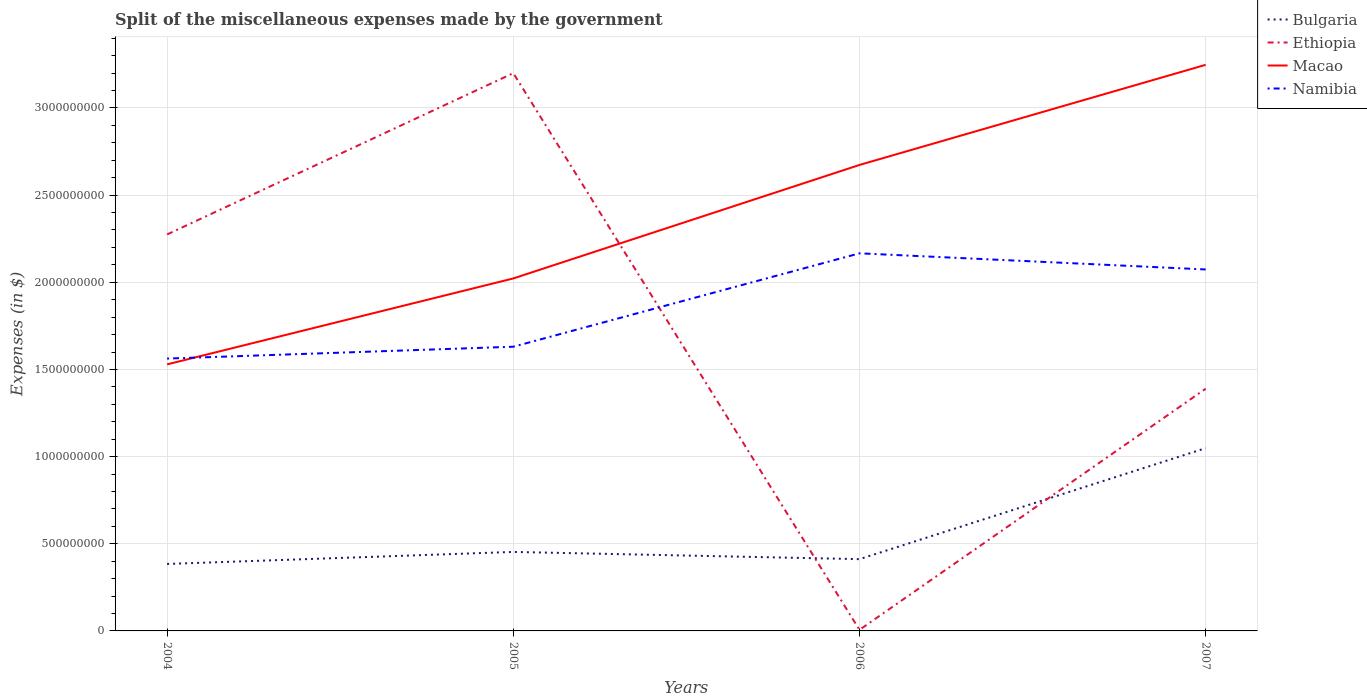How many different coloured lines are there?
Your answer should be very brief. 4. Is the number of lines equal to the number of legend labels?
Offer a very short reply. Yes. Across all years, what is the maximum miscellaneous expenses made by the government in Macao?
Ensure brevity in your answer.  1.53e+09. In which year was the miscellaneous expenses made by the government in Ethiopia maximum?
Keep it short and to the point. 2006. What is the total miscellaneous expenses made by the government in Macao in the graph?
Offer a very short reply. -1.14e+09. What is the difference between the highest and the second highest miscellaneous expenses made by the government in Macao?
Provide a short and direct response. 1.72e+09. Is the miscellaneous expenses made by the government in Bulgaria strictly greater than the miscellaneous expenses made by the government in Ethiopia over the years?
Your response must be concise. No. How many years are there in the graph?
Offer a terse response. 4. Does the graph contain any zero values?
Your response must be concise. No. Where does the legend appear in the graph?
Provide a short and direct response. Top right. How many legend labels are there?
Offer a terse response. 4. What is the title of the graph?
Ensure brevity in your answer.  Split of the miscellaneous expenses made by the government. Does "Sub-Saharan Africa (developing only)" appear as one of the legend labels in the graph?
Provide a succinct answer. No. What is the label or title of the Y-axis?
Make the answer very short. Expenses (in $). What is the Expenses (in $) of Bulgaria in 2004?
Your response must be concise. 3.84e+08. What is the Expenses (in $) of Ethiopia in 2004?
Make the answer very short. 2.27e+09. What is the Expenses (in $) of Macao in 2004?
Your answer should be compact. 1.53e+09. What is the Expenses (in $) of Namibia in 2004?
Keep it short and to the point. 1.56e+09. What is the Expenses (in $) of Bulgaria in 2005?
Your answer should be very brief. 4.53e+08. What is the Expenses (in $) in Ethiopia in 2005?
Ensure brevity in your answer.  3.20e+09. What is the Expenses (in $) in Macao in 2005?
Your answer should be very brief. 2.02e+09. What is the Expenses (in $) of Namibia in 2005?
Your answer should be compact. 1.63e+09. What is the Expenses (in $) of Bulgaria in 2006?
Offer a very short reply. 4.12e+08. What is the Expenses (in $) of Ethiopia in 2006?
Your response must be concise. 6.20e+06. What is the Expenses (in $) of Macao in 2006?
Your response must be concise. 2.67e+09. What is the Expenses (in $) of Namibia in 2006?
Your response must be concise. 2.17e+09. What is the Expenses (in $) of Bulgaria in 2007?
Keep it short and to the point. 1.05e+09. What is the Expenses (in $) in Ethiopia in 2007?
Ensure brevity in your answer.  1.39e+09. What is the Expenses (in $) in Macao in 2007?
Make the answer very short. 3.25e+09. What is the Expenses (in $) of Namibia in 2007?
Give a very brief answer. 2.07e+09. Across all years, what is the maximum Expenses (in $) in Bulgaria?
Provide a short and direct response. 1.05e+09. Across all years, what is the maximum Expenses (in $) in Ethiopia?
Your response must be concise. 3.20e+09. Across all years, what is the maximum Expenses (in $) in Macao?
Offer a terse response. 3.25e+09. Across all years, what is the maximum Expenses (in $) in Namibia?
Make the answer very short. 2.17e+09. Across all years, what is the minimum Expenses (in $) of Bulgaria?
Offer a terse response. 3.84e+08. Across all years, what is the minimum Expenses (in $) in Ethiopia?
Ensure brevity in your answer.  6.20e+06. Across all years, what is the minimum Expenses (in $) of Macao?
Offer a very short reply. 1.53e+09. Across all years, what is the minimum Expenses (in $) of Namibia?
Give a very brief answer. 1.56e+09. What is the total Expenses (in $) of Bulgaria in the graph?
Make the answer very short. 2.30e+09. What is the total Expenses (in $) in Ethiopia in the graph?
Provide a succinct answer. 6.87e+09. What is the total Expenses (in $) of Macao in the graph?
Ensure brevity in your answer.  9.47e+09. What is the total Expenses (in $) in Namibia in the graph?
Your response must be concise. 7.43e+09. What is the difference between the Expenses (in $) of Bulgaria in 2004 and that in 2005?
Your answer should be compact. -6.90e+07. What is the difference between the Expenses (in $) in Ethiopia in 2004 and that in 2005?
Offer a terse response. -9.25e+08. What is the difference between the Expenses (in $) of Macao in 2004 and that in 2005?
Your answer should be very brief. -4.93e+08. What is the difference between the Expenses (in $) in Namibia in 2004 and that in 2005?
Your response must be concise. -6.80e+07. What is the difference between the Expenses (in $) of Bulgaria in 2004 and that in 2006?
Keep it short and to the point. -2.76e+07. What is the difference between the Expenses (in $) in Ethiopia in 2004 and that in 2006?
Offer a terse response. 2.27e+09. What is the difference between the Expenses (in $) of Macao in 2004 and that in 2006?
Your answer should be compact. -1.14e+09. What is the difference between the Expenses (in $) in Namibia in 2004 and that in 2006?
Make the answer very short. -6.04e+08. What is the difference between the Expenses (in $) of Bulgaria in 2004 and that in 2007?
Your answer should be very brief. -6.64e+08. What is the difference between the Expenses (in $) of Ethiopia in 2004 and that in 2007?
Offer a very short reply. 8.85e+08. What is the difference between the Expenses (in $) in Macao in 2004 and that in 2007?
Your answer should be compact. -1.72e+09. What is the difference between the Expenses (in $) in Namibia in 2004 and that in 2007?
Keep it short and to the point. -5.11e+08. What is the difference between the Expenses (in $) of Bulgaria in 2005 and that in 2006?
Give a very brief answer. 4.15e+07. What is the difference between the Expenses (in $) of Ethiopia in 2005 and that in 2006?
Give a very brief answer. 3.19e+09. What is the difference between the Expenses (in $) of Macao in 2005 and that in 2006?
Give a very brief answer. -6.51e+08. What is the difference between the Expenses (in $) of Namibia in 2005 and that in 2006?
Make the answer very short. -5.36e+08. What is the difference between the Expenses (in $) in Bulgaria in 2005 and that in 2007?
Your answer should be compact. -5.95e+08. What is the difference between the Expenses (in $) of Ethiopia in 2005 and that in 2007?
Provide a succinct answer. 1.81e+09. What is the difference between the Expenses (in $) in Macao in 2005 and that in 2007?
Provide a succinct answer. -1.23e+09. What is the difference between the Expenses (in $) of Namibia in 2005 and that in 2007?
Offer a terse response. -4.43e+08. What is the difference between the Expenses (in $) of Bulgaria in 2006 and that in 2007?
Your response must be concise. -6.37e+08. What is the difference between the Expenses (in $) in Ethiopia in 2006 and that in 2007?
Make the answer very short. -1.38e+09. What is the difference between the Expenses (in $) of Macao in 2006 and that in 2007?
Your answer should be compact. -5.74e+08. What is the difference between the Expenses (in $) in Namibia in 2006 and that in 2007?
Your response must be concise. 9.26e+07. What is the difference between the Expenses (in $) in Bulgaria in 2004 and the Expenses (in $) in Ethiopia in 2005?
Offer a terse response. -2.82e+09. What is the difference between the Expenses (in $) of Bulgaria in 2004 and the Expenses (in $) of Macao in 2005?
Your response must be concise. -1.64e+09. What is the difference between the Expenses (in $) in Bulgaria in 2004 and the Expenses (in $) in Namibia in 2005?
Ensure brevity in your answer.  -1.25e+09. What is the difference between the Expenses (in $) in Ethiopia in 2004 and the Expenses (in $) in Macao in 2005?
Your response must be concise. 2.52e+08. What is the difference between the Expenses (in $) of Ethiopia in 2004 and the Expenses (in $) of Namibia in 2005?
Your answer should be very brief. 6.44e+08. What is the difference between the Expenses (in $) in Macao in 2004 and the Expenses (in $) in Namibia in 2005?
Provide a short and direct response. -1.01e+08. What is the difference between the Expenses (in $) in Bulgaria in 2004 and the Expenses (in $) in Ethiopia in 2006?
Make the answer very short. 3.78e+08. What is the difference between the Expenses (in $) of Bulgaria in 2004 and the Expenses (in $) of Macao in 2006?
Make the answer very short. -2.29e+09. What is the difference between the Expenses (in $) in Bulgaria in 2004 and the Expenses (in $) in Namibia in 2006?
Make the answer very short. -1.78e+09. What is the difference between the Expenses (in $) of Ethiopia in 2004 and the Expenses (in $) of Macao in 2006?
Provide a succinct answer. -3.99e+08. What is the difference between the Expenses (in $) in Ethiopia in 2004 and the Expenses (in $) in Namibia in 2006?
Keep it short and to the point. 1.08e+08. What is the difference between the Expenses (in $) in Macao in 2004 and the Expenses (in $) in Namibia in 2006?
Provide a short and direct response. -6.37e+08. What is the difference between the Expenses (in $) of Bulgaria in 2004 and the Expenses (in $) of Ethiopia in 2007?
Make the answer very short. -1.01e+09. What is the difference between the Expenses (in $) of Bulgaria in 2004 and the Expenses (in $) of Macao in 2007?
Keep it short and to the point. -2.86e+09. What is the difference between the Expenses (in $) of Bulgaria in 2004 and the Expenses (in $) of Namibia in 2007?
Offer a terse response. -1.69e+09. What is the difference between the Expenses (in $) in Ethiopia in 2004 and the Expenses (in $) in Macao in 2007?
Offer a very short reply. -9.73e+08. What is the difference between the Expenses (in $) of Ethiopia in 2004 and the Expenses (in $) of Namibia in 2007?
Give a very brief answer. 2.01e+08. What is the difference between the Expenses (in $) in Macao in 2004 and the Expenses (in $) in Namibia in 2007?
Ensure brevity in your answer.  -5.44e+08. What is the difference between the Expenses (in $) in Bulgaria in 2005 and the Expenses (in $) in Ethiopia in 2006?
Offer a terse response. 4.47e+08. What is the difference between the Expenses (in $) of Bulgaria in 2005 and the Expenses (in $) of Macao in 2006?
Make the answer very short. -2.22e+09. What is the difference between the Expenses (in $) of Bulgaria in 2005 and the Expenses (in $) of Namibia in 2006?
Give a very brief answer. -1.71e+09. What is the difference between the Expenses (in $) of Ethiopia in 2005 and the Expenses (in $) of Macao in 2006?
Give a very brief answer. 5.27e+08. What is the difference between the Expenses (in $) of Ethiopia in 2005 and the Expenses (in $) of Namibia in 2006?
Ensure brevity in your answer.  1.03e+09. What is the difference between the Expenses (in $) of Macao in 2005 and the Expenses (in $) of Namibia in 2006?
Your response must be concise. -1.44e+08. What is the difference between the Expenses (in $) in Bulgaria in 2005 and the Expenses (in $) in Ethiopia in 2007?
Your answer should be very brief. -9.36e+08. What is the difference between the Expenses (in $) of Bulgaria in 2005 and the Expenses (in $) of Macao in 2007?
Keep it short and to the point. -2.79e+09. What is the difference between the Expenses (in $) of Bulgaria in 2005 and the Expenses (in $) of Namibia in 2007?
Provide a succinct answer. -1.62e+09. What is the difference between the Expenses (in $) in Ethiopia in 2005 and the Expenses (in $) in Macao in 2007?
Your answer should be compact. -4.77e+07. What is the difference between the Expenses (in $) of Ethiopia in 2005 and the Expenses (in $) of Namibia in 2007?
Keep it short and to the point. 1.13e+09. What is the difference between the Expenses (in $) of Macao in 2005 and the Expenses (in $) of Namibia in 2007?
Offer a very short reply. -5.15e+07. What is the difference between the Expenses (in $) of Bulgaria in 2006 and the Expenses (in $) of Ethiopia in 2007?
Ensure brevity in your answer.  -9.78e+08. What is the difference between the Expenses (in $) in Bulgaria in 2006 and the Expenses (in $) in Macao in 2007?
Your answer should be compact. -2.84e+09. What is the difference between the Expenses (in $) of Bulgaria in 2006 and the Expenses (in $) of Namibia in 2007?
Offer a terse response. -1.66e+09. What is the difference between the Expenses (in $) in Ethiopia in 2006 and the Expenses (in $) in Macao in 2007?
Your answer should be compact. -3.24e+09. What is the difference between the Expenses (in $) in Ethiopia in 2006 and the Expenses (in $) in Namibia in 2007?
Give a very brief answer. -2.07e+09. What is the difference between the Expenses (in $) of Macao in 2006 and the Expenses (in $) of Namibia in 2007?
Provide a succinct answer. 6.00e+08. What is the average Expenses (in $) of Bulgaria per year?
Your response must be concise. 5.74e+08. What is the average Expenses (in $) of Ethiopia per year?
Provide a short and direct response. 1.72e+09. What is the average Expenses (in $) in Macao per year?
Your answer should be very brief. 2.37e+09. What is the average Expenses (in $) of Namibia per year?
Your answer should be compact. 1.86e+09. In the year 2004, what is the difference between the Expenses (in $) of Bulgaria and Expenses (in $) of Ethiopia?
Provide a succinct answer. -1.89e+09. In the year 2004, what is the difference between the Expenses (in $) in Bulgaria and Expenses (in $) in Macao?
Offer a very short reply. -1.14e+09. In the year 2004, what is the difference between the Expenses (in $) of Bulgaria and Expenses (in $) of Namibia?
Your answer should be compact. -1.18e+09. In the year 2004, what is the difference between the Expenses (in $) in Ethiopia and Expenses (in $) in Macao?
Your answer should be very brief. 7.45e+08. In the year 2004, what is the difference between the Expenses (in $) in Ethiopia and Expenses (in $) in Namibia?
Make the answer very short. 7.12e+08. In the year 2004, what is the difference between the Expenses (in $) of Macao and Expenses (in $) of Namibia?
Your answer should be very brief. -3.33e+07. In the year 2005, what is the difference between the Expenses (in $) of Bulgaria and Expenses (in $) of Ethiopia?
Offer a very short reply. -2.75e+09. In the year 2005, what is the difference between the Expenses (in $) in Bulgaria and Expenses (in $) in Macao?
Your answer should be very brief. -1.57e+09. In the year 2005, what is the difference between the Expenses (in $) of Bulgaria and Expenses (in $) of Namibia?
Give a very brief answer. -1.18e+09. In the year 2005, what is the difference between the Expenses (in $) of Ethiopia and Expenses (in $) of Macao?
Provide a succinct answer. 1.18e+09. In the year 2005, what is the difference between the Expenses (in $) of Ethiopia and Expenses (in $) of Namibia?
Give a very brief answer. 1.57e+09. In the year 2005, what is the difference between the Expenses (in $) in Macao and Expenses (in $) in Namibia?
Your response must be concise. 3.92e+08. In the year 2006, what is the difference between the Expenses (in $) in Bulgaria and Expenses (in $) in Ethiopia?
Ensure brevity in your answer.  4.05e+08. In the year 2006, what is the difference between the Expenses (in $) in Bulgaria and Expenses (in $) in Macao?
Offer a very short reply. -2.26e+09. In the year 2006, what is the difference between the Expenses (in $) of Bulgaria and Expenses (in $) of Namibia?
Give a very brief answer. -1.75e+09. In the year 2006, what is the difference between the Expenses (in $) of Ethiopia and Expenses (in $) of Macao?
Offer a very short reply. -2.67e+09. In the year 2006, what is the difference between the Expenses (in $) of Ethiopia and Expenses (in $) of Namibia?
Your response must be concise. -2.16e+09. In the year 2006, what is the difference between the Expenses (in $) in Macao and Expenses (in $) in Namibia?
Ensure brevity in your answer.  5.07e+08. In the year 2007, what is the difference between the Expenses (in $) in Bulgaria and Expenses (in $) in Ethiopia?
Your response must be concise. -3.41e+08. In the year 2007, what is the difference between the Expenses (in $) of Bulgaria and Expenses (in $) of Macao?
Make the answer very short. -2.20e+09. In the year 2007, what is the difference between the Expenses (in $) in Bulgaria and Expenses (in $) in Namibia?
Provide a short and direct response. -1.03e+09. In the year 2007, what is the difference between the Expenses (in $) in Ethiopia and Expenses (in $) in Macao?
Keep it short and to the point. -1.86e+09. In the year 2007, what is the difference between the Expenses (in $) of Ethiopia and Expenses (in $) of Namibia?
Your answer should be compact. -6.84e+08. In the year 2007, what is the difference between the Expenses (in $) of Macao and Expenses (in $) of Namibia?
Your answer should be very brief. 1.17e+09. What is the ratio of the Expenses (in $) of Bulgaria in 2004 to that in 2005?
Provide a succinct answer. 0.85. What is the ratio of the Expenses (in $) of Ethiopia in 2004 to that in 2005?
Offer a very short reply. 0.71. What is the ratio of the Expenses (in $) of Macao in 2004 to that in 2005?
Your answer should be compact. 0.76. What is the ratio of the Expenses (in $) of Namibia in 2004 to that in 2005?
Provide a succinct answer. 0.96. What is the ratio of the Expenses (in $) in Bulgaria in 2004 to that in 2006?
Offer a very short reply. 0.93. What is the ratio of the Expenses (in $) of Ethiopia in 2004 to that in 2006?
Ensure brevity in your answer.  366.84. What is the ratio of the Expenses (in $) of Macao in 2004 to that in 2006?
Offer a terse response. 0.57. What is the ratio of the Expenses (in $) in Namibia in 2004 to that in 2006?
Provide a succinct answer. 0.72. What is the ratio of the Expenses (in $) in Bulgaria in 2004 to that in 2007?
Your response must be concise. 0.37. What is the ratio of the Expenses (in $) of Ethiopia in 2004 to that in 2007?
Your answer should be compact. 1.64. What is the ratio of the Expenses (in $) in Macao in 2004 to that in 2007?
Keep it short and to the point. 0.47. What is the ratio of the Expenses (in $) of Namibia in 2004 to that in 2007?
Provide a short and direct response. 0.75. What is the ratio of the Expenses (in $) in Bulgaria in 2005 to that in 2006?
Your answer should be compact. 1.1. What is the ratio of the Expenses (in $) in Ethiopia in 2005 to that in 2006?
Your answer should be compact. 516.06. What is the ratio of the Expenses (in $) in Macao in 2005 to that in 2006?
Make the answer very short. 0.76. What is the ratio of the Expenses (in $) in Namibia in 2005 to that in 2006?
Offer a very short reply. 0.75. What is the ratio of the Expenses (in $) in Bulgaria in 2005 to that in 2007?
Your answer should be compact. 0.43. What is the ratio of the Expenses (in $) of Ethiopia in 2005 to that in 2007?
Provide a succinct answer. 2.3. What is the ratio of the Expenses (in $) in Macao in 2005 to that in 2007?
Your response must be concise. 0.62. What is the ratio of the Expenses (in $) of Namibia in 2005 to that in 2007?
Make the answer very short. 0.79. What is the ratio of the Expenses (in $) in Bulgaria in 2006 to that in 2007?
Your answer should be very brief. 0.39. What is the ratio of the Expenses (in $) of Ethiopia in 2006 to that in 2007?
Provide a short and direct response. 0. What is the ratio of the Expenses (in $) of Macao in 2006 to that in 2007?
Offer a very short reply. 0.82. What is the ratio of the Expenses (in $) in Namibia in 2006 to that in 2007?
Your answer should be compact. 1.04. What is the difference between the highest and the second highest Expenses (in $) in Bulgaria?
Your answer should be compact. 5.95e+08. What is the difference between the highest and the second highest Expenses (in $) of Ethiopia?
Give a very brief answer. 9.25e+08. What is the difference between the highest and the second highest Expenses (in $) of Macao?
Provide a short and direct response. 5.74e+08. What is the difference between the highest and the second highest Expenses (in $) of Namibia?
Make the answer very short. 9.26e+07. What is the difference between the highest and the lowest Expenses (in $) in Bulgaria?
Your answer should be very brief. 6.64e+08. What is the difference between the highest and the lowest Expenses (in $) in Ethiopia?
Ensure brevity in your answer.  3.19e+09. What is the difference between the highest and the lowest Expenses (in $) of Macao?
Give a very brief answer. 1.72e+09. What is the difference between the highest and the lowest Expenses (in $) of Namibia?
Offer a terse response. 6.04e+08. 